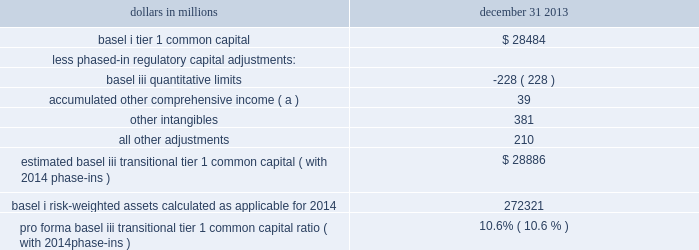Table 20 : pro forma transitional basel iii tier 1 common capital ratio dollars in millions december 31 .
Estimated basel iii transitional tier 1 common capital ( with 2014 phase-ins ) $ 28886 basel i risk-weighted assets calculated as applicable for 2014 272321 pro forma basel iii transitional tier 1 common capital ratio ( with 2014 phase-ins ) 10.6% ( 10.6 % ) ( a ) represents net adjustments related to accumulated other comprehensive income for available for sale securities and pension and other postretirement benefit plans .
Pnc utilizes these fully implemented and transitional basel iii capital ratios to assess its capital position , including comparison to similar estimates made by other financial institutions .
These basel iii capital estimates are likely to be impacted by any additional regulatory guidance , continued analysis by pnc as to the application of the rules to pnc , and in the case of ratios calculated using the advanced approaches , the ongoing evolution , validation and regulatory approval of pnc 2019s models integral to the calculation of advanced approaches risk-weighted assets .
The access to and cost of funding for new business initiatives , the ability to undertake new business initiatives including acquisitions , the ability to engage in expanded business activities , the ability to pay dividends or repurchase shares or other capital instruments , the level of deposit insurance costs , and the level and nature of regulatory oversight depend , in large part , on a financial institution 2019s capital strength .
We provide additional information regarding enhanced capital requirements and some of their potential impacts on pnc in item 1 business 2013 supervision and regulation , item 1a risk factors and note 22 regulatory matters in the notes to consolidated financial statements in item 8 of this report .
Off-balance sheet arrangements and variable interest entities we engage in a variety of activities that involve unconsolidated entities or that are otherwise not reflected in our consolidated balance sheet that are generally referred to as 201coff-balance sheet arrangements . 201d additional information on these types of activities is included in the following sections of this report : 2022 commitments , including contractual obligations and other commitments , included within the risk management section of this item 7 , 2022 note 3 loan sale and servicing activities and variable interest entities in the notes to consolidated financial statements included in item 8 of this report , 2022 note 14 capital securities of subsidiary trusts and perpetual trust securities in the notes to consolidated financial statements included in item 8 of this report , and 2022 note 24 commitments and guarantees in the notes to consolidated financial statements included in item 8 of this report .
Pnc consolidates variable interest entities ( vies ) when we are deemed to be the primary beneficiary .
The primary beneficiary of a vie is determined to be the party that meets both of the following criteria : ( i ) has the power to make decisions that most significantly affect the economic performance of the vie ; and ( ii ) has the obligation to absorb losses or the right to receive benefits that in either case could potentially be significant to the vie .
A summary of vies , including those that we have consolidated and those in which we hold variable interests but have not consolidated into our financial statements , as of december 31 , 2013 and december 31 , 2012 is included in note 3 in the notes to consolidated financial statements included in item 8 of this report .
Trust preferred securities and reit preferred securities we are subject to certain restrictions , including restrictions on dividend payments , in connection with $ 206 million in principal amount of an outstanding junior subordinated debenture associated with $ 200 million of trust preferred securities ( both amounts as of december 31 , 2013 ) that were issued by pnc capital trust c , a subsidiary statutory trust .
Generally , if there is ( i ) an event of default under the debenture , ( ii ) pnc elects to defer interest on the debenture , ( iii ) pnc exercises its right to defer payments on the related trust preferred security issued by the statutory trust , or ( iv ) there is a default under pnc 2019s guarantee of such payment obligations , as specified in the applicable governing documents , then pnc would be subject during the period of such default or deferral to restrictions on dividends and other provisions protecting the status of the debenture holders similar to or in some ways more restrictive than those potentially imposed under the exchange agreement with pnc preferred funding trust ii .
See note 14 capital securities of subsidiary trusts and perpetual trust securities in the notes to consolidated financial statements in item 8 of this report for additional information on contractual limitations on dividend payments resulting from securities issued by pnc preferred funding trust i and pnc preferred funding trust ii .
See the liquidity risk management portion of the risk management section of this item 7 for additional information regarding our first quarter 2013 redemption of the reit preferred securities issued by pnc preferred funding trust iii and additional discussion of redemptions of trust preferred securities .
48 the pnc financial services group , inc .
2013 form 10-k .
For 2013 , was the basel i tier 1 common capital $ 28484 without phased-in regulatory capital adjustments greater than estimated basel iii transitional tier 1 common capital with 2014 phase-ins? 
Computations: (28484 > 28886)
Answer: no. 